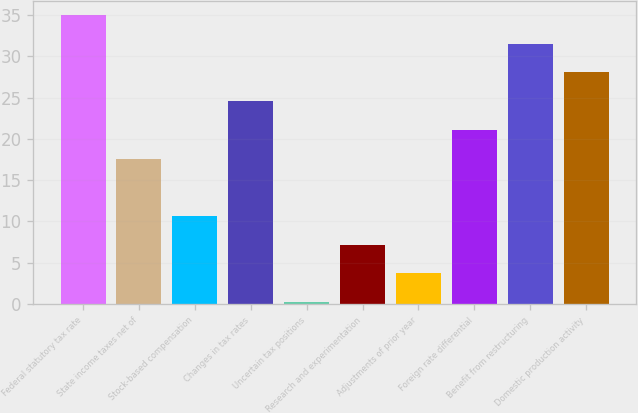Convert chart. <chart><loc_0><loc_0><loc_500><loc_500><bar_chart><fcel>Federal statutory tax rate<fcel>State income taxes net of<fcel>Stock-based compensation<fcel>Changes in tax rates<fcel>Uncertain tax positions<fcel>Research and experimentation<fcel>Adjustments of prior year<fcel>Foreign rate differential<fcel>Benefit from restructuring<fcel>Domestic production activity<nl><fcel>35<fcel>17.6<fcel>10.64<fcel>24.56<fcel>0.2<fcel>7.16<fcel>3.68<fcel>21.08<fcel>31.52<fcel>28.04<nl></chart> 